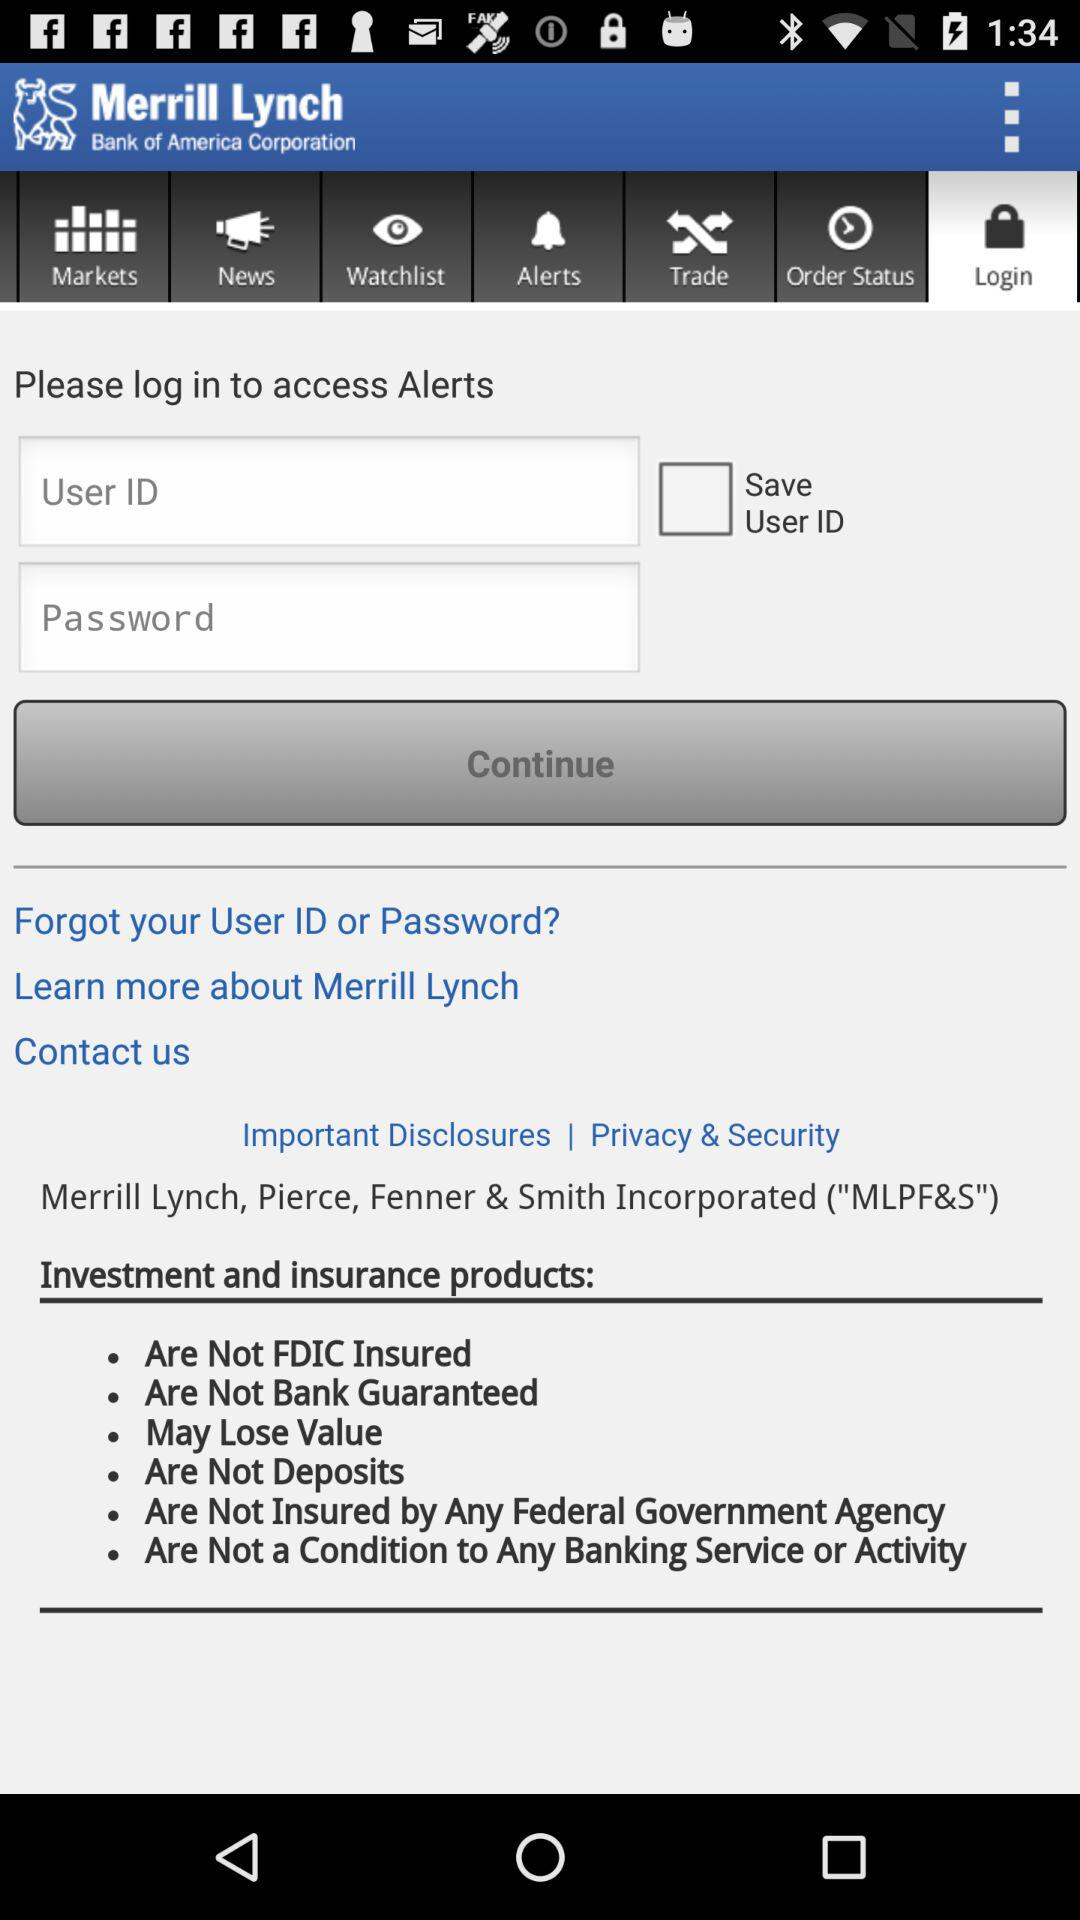What is the full form of the MLPF&S? The full form of the MLPF&S is Merrill Lynch, Pierce, Fenner & Smith Incorporated. 